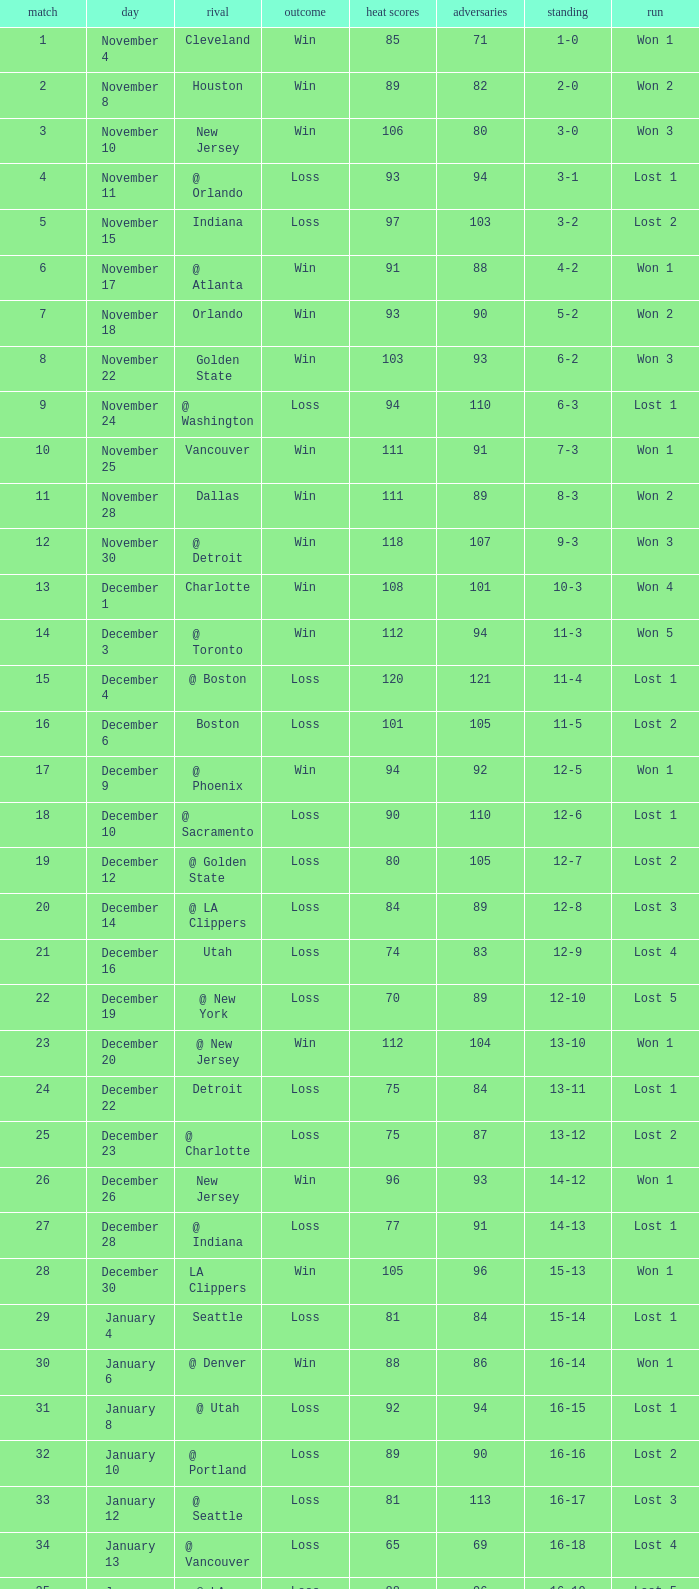What is the highest Game, when Opponents is less than 80, and when Record is "1-0"? 1.0. 